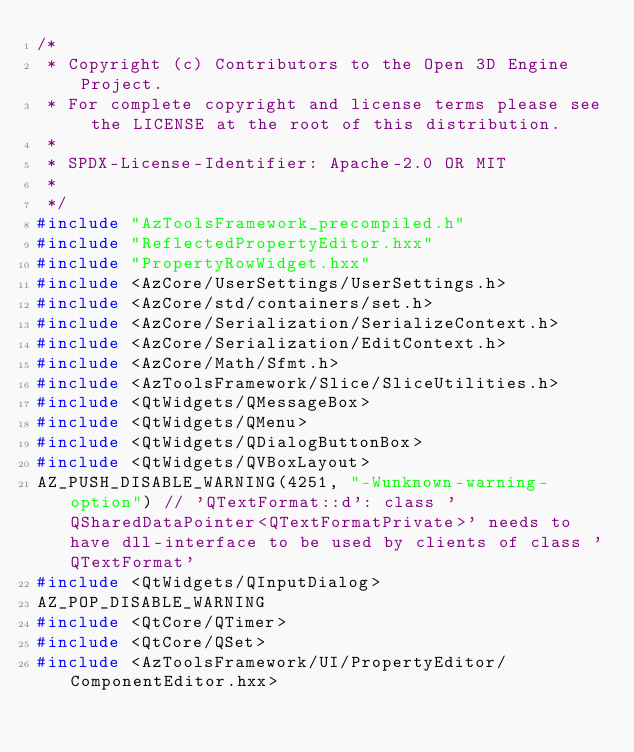<code> <loc_0><loc_0><loc_500><loc_500><_C++_>/*
 * Copyright (c) Contributors to the Open 3D Engine Project.
 * For complete copyright and license terms please see the LICENSE at the root of this distribution.
 *
 * SPDX-License-Identifier: Apache-2.0 OR MIT
 *
 */
#include "AzToolsFramework_precompiled.h"
#include "ReflectedPropertyEditor.hxx"
#include "PropertyRowWidget.hxx"
#include <AzCore/UserSettings/UserSettings.h>
#include <AzCore/std/containers/set.h>
#include <AzCore/Serialization/SerializeContext.h>
#include <AzCore/Serialization/EditContext.h>
#include <AzCore/Math/Sfmt.h>
#include <AzToolsFramework/Slice/SliceUtilities.h>
#include <QtWidgets/QMessageBox>
#include <QtWidgets/QMenu>
#include <QtWidgets/QDialogButtonBox>
#include <QtWidgets/QVBoxLayout>
AZ_PUSH_DISABLE_WARNING(4251, "-Wunknown-warning-option") // 'QTextFormat::d': class 'QSharedDataPointer<QTextFormatPrivate>' needs to have dll-interface to be used by clients of class 'QTextFormat'
#include <QtWidgets/QInputDialog>
AZ_POP_DISABLE_WARNING
#include <QtCore/QTimer>
#include <QtCore/QSet>
#include <AzToolsFramework/UI/PropertyEditor/ComponentEditor.hxx></code> 